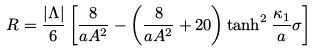Convert formula to latex. <formula><loc_0><loc_0><loc_500><loc_500>R = \frac { | \Lambda | } { 6 } \left [ \frac { 8 } { a A ^ { 2 } } - \left ( \frac { 8 } { a A ^ { 2 } } + 2 0 \right ) \tanh ^ { 2 } \frac { \kappa _ { 1 } } { a } \sigma \right ]</formula> 